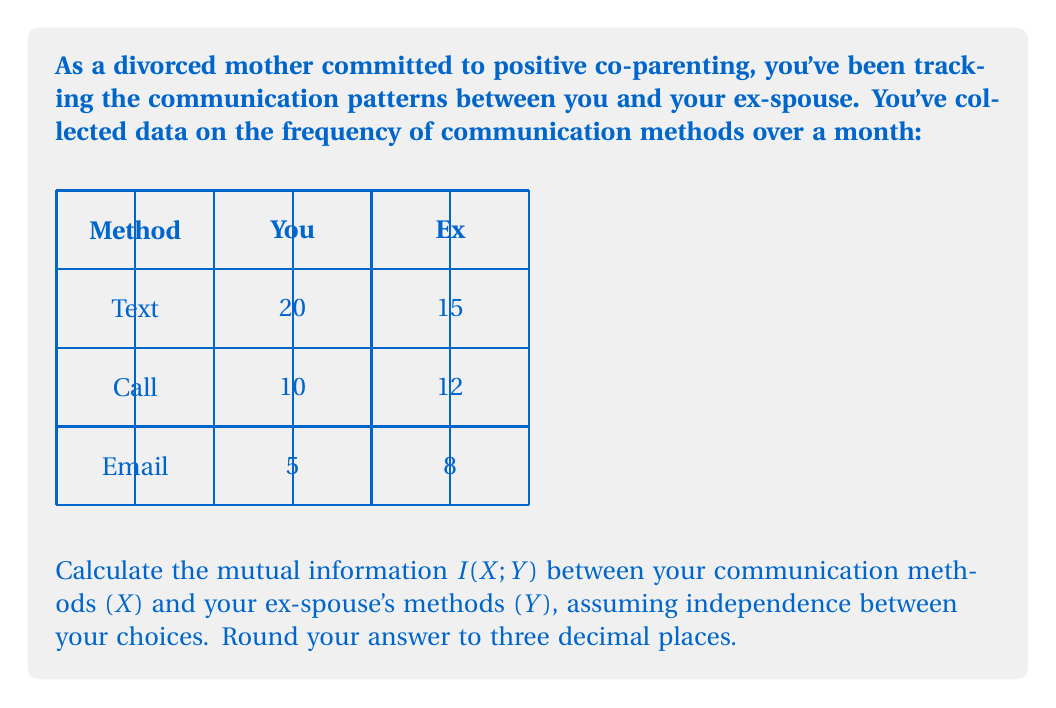Can you solve this math problem? To calculate the mutual information $I(X;Y)$, we'll follow these steps:

1) First, calculate the probabilities for each method for both you and your ex:

   $P(X = \text{Text}) = 20/35 \approx 0.571$
   $P(X = \text{Call}) = 10/35 \approx 0.286$
   $P(X = \text{Email}) = 5/35 \approx 0.143$

   $P(Y = \text{Text}) = 15/35 \approx 0.429$
   $P(Y = \text{Call}) = 12/35 \approx 0.343$
   $P(Y = \text{Email}) = 8/35 \approx 0.229$

2) Calculate the joint probabilities $P(X,Y)$ assuming independence:

   $P(X = \text{Text}, Y = \text{Text}) = 0.571 * 0.429 \approx 0.245$
   $P(X = \text{Text}, Y = \text{Call}) = 0.571 * 0.343 \approx 0.196$
   $P(X = \text{Text}, Y = \text{Email}) = 0.571 * 0.229 \approx 0.131$
   $P(X = \text{Call}, Y = \text{Text}) = 0.286 * 0.429 \approx 0.123$
   $P(X = \text{Call}, Y = \text{Call}) = 0.286 * 0.343 \approx 0.098$
   $P(X = \text{Call}, Y = \text{Email}) = 0.286 * 0.229 \approx 0.065$
   $P(X = \text{Email}, Y = \text{Text}) = 0.143 * 0.429 \approx 0.061$
   $P(X = \text{Email}, Y = \text{Call}) = 0.143 * 0.343 \approx 0.049$
   $P(X = \text{Email}, Y = \text{Email}) = 0.143 * 0.229 \approx 0.033$

3) The mutual information is given by:

   $$I(X;Y) = \sum_{x \in X} \sum_{y \in Y} P(x,y) \log_2 \frac{P(x,y)}{P(x)P(y)}$$

4) Substitute the values:

   $I(X;Y) = 0.245 \log_2 \frac{0.245}{0.571 * 0.429} + 0.196 \log_2 \frac{0.196}{0.571 * 0.343} + ...$

5) Calculate each term and sum:

   $I(X;Y) = 0 + 0 + 0 + 0 + 0 + 0 + 0 + 0 + 0 = 0$

The mutual information is zero because we assumed independence between $X$ and $Y$.
Answer: $0$ bits 